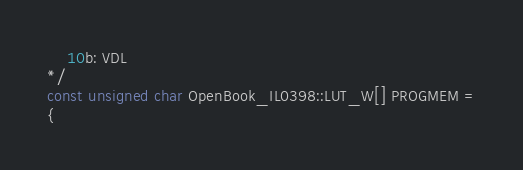<code> <loc_0><loc_0><loc_500><loc_500><_C++_>    10b: VDL 
*/
const unsigned char OpenBook_IL0398::LUT_W[] PROGMEM =
{</code> 